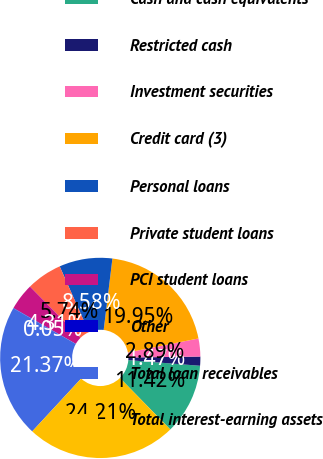Convert chart to OTSL. <chart><loc_0><loc_0><loc_500><loc_500><pie_chart><fcel>Cash and cash equivalents<fcel>Restricted cash<fcel>Investment securities<fcel>Credit card (3)<fcel>Personal loans<fcel>Private student loans<fcel>PCI student loans<fcel>Other<fcel>Total loan receivables<fcel>Total interest-earning assets<nl><fcel>11.42%<fcel>1.47%<fcel>2.89%<fcel>19.95%<fcel>8.58%<fcel>5.74%<fcel>4.31%<fcel>0.05%<fcel>21.37%<fcel>24.21%<nl></chart> 